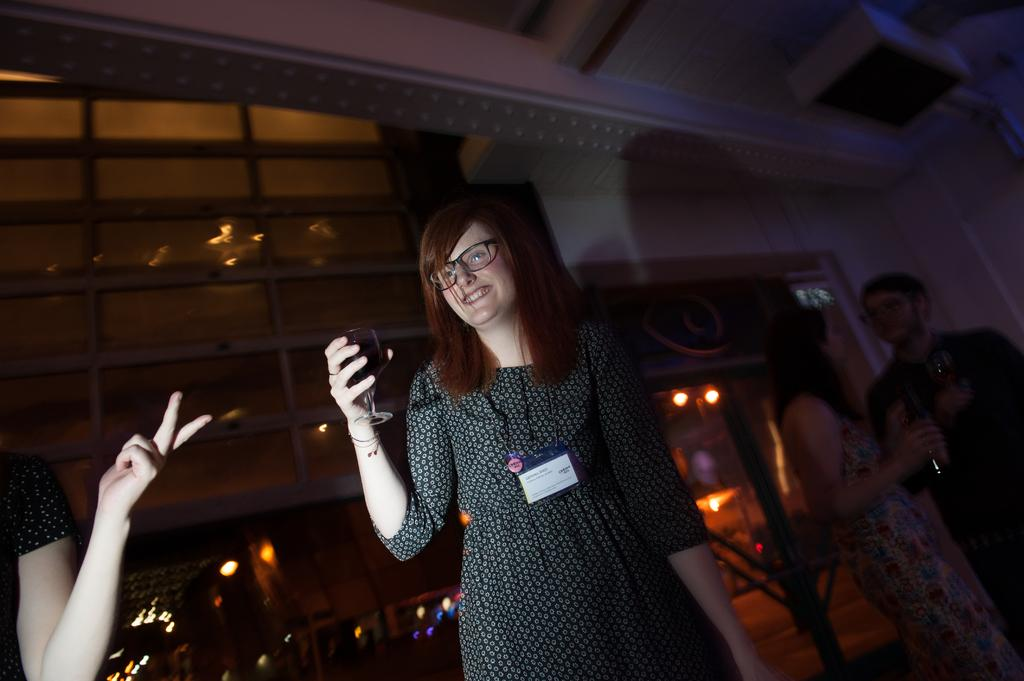Who is the main subject in the image? There is a girl in the image. Can you describe the girl's position in the image? The girl is standing in the front. What is the girl holding in the image? The girl is holding a wine glass. What can be seen in the background of the image? There is a glass wall in the background of the image. What type of vase is the girl's uncle holding in the image? There is no vase or uncle present in the image. 